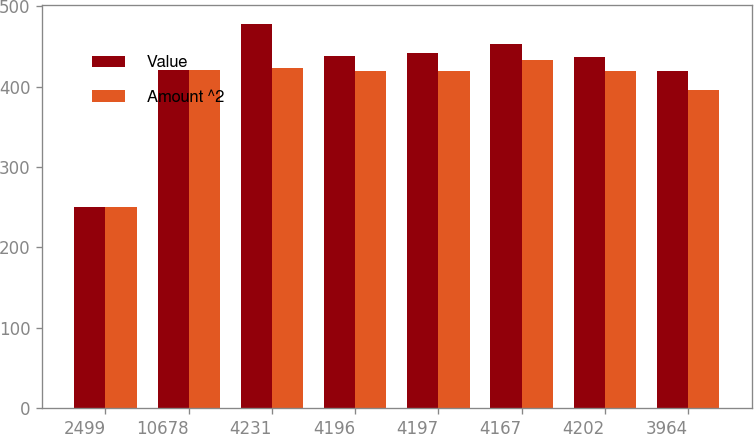Convert chart. <chart><loc_0><loc_0><loc_500><loc_500><stacked_bar_chart><ecel><fcel>2499<fcel>10678<fcel>4231<fcel>4196<fcel>4197<fcel>4167<fcel>4202<fcel>3964<nl><fcel>Value<fcel>249.9<fcel>421.2<fcel>477.3<fcel>437.6<fcel>441.1<fcel>453.4<fcel>437.3<fcel>418.8<nl><fcel>Amount ^2<fcel>249.7<fcel>421.2<fcel>422.7<fcel>418.9<fcel>419<fcel>432.9<fcel>419.7<fcel>396.1<nl></chart> 